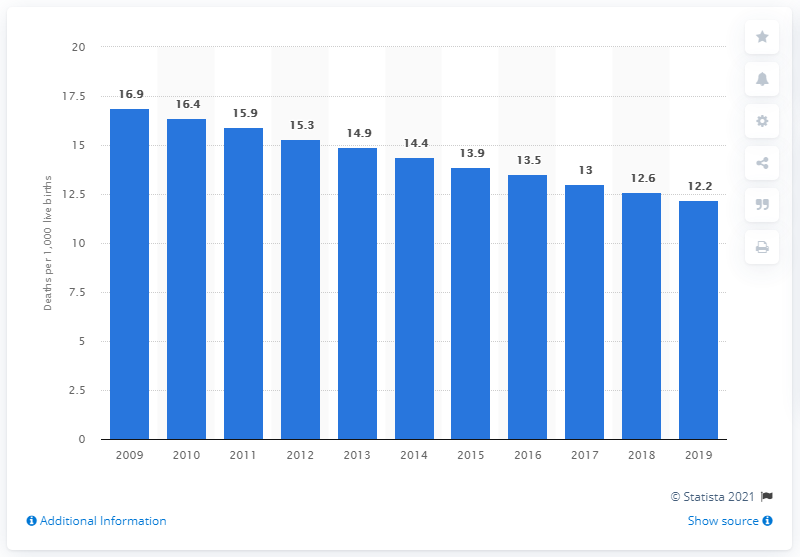Specify some key components in this picture. In 2019, the infant mortality rate in Mexico was 12.2, indicating a decline in the number of infant deaths compared to previous years. 